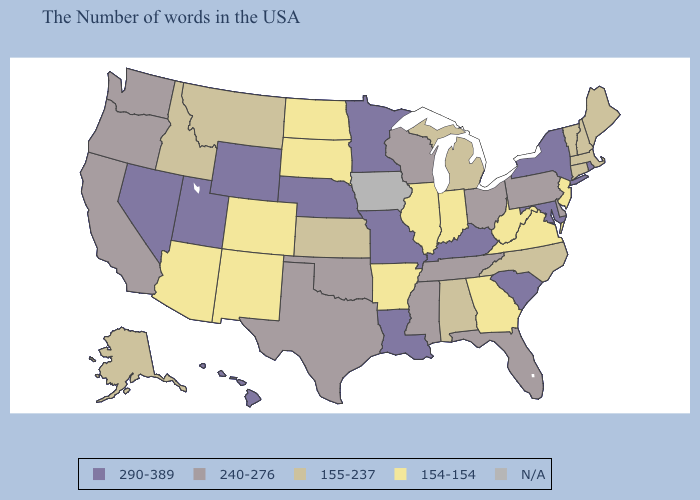Name the states that have a value in the range 154-154?
Give a very brief answer. New Jersey, Virginia, West Virginia, Georgia, Indiana, Illinois, Arkansas, South Dakota, North Dakota, Colorado, New Mexico, Arizona. Which states hav the highest value in the West?
Keep it brief. Wyoming, Utah, Nevada, Hawaii. Among the states that border Nebraska , does Wyoming have the lowest value?
Answer briefly. No. Among the states that border Arizona , which have the highest value?
Answer briefly. Utah, Nevada. Does Nevada have the highest value in the USA?
Give a very brief answer. Yes. Which states have the lowest value in the USA?
Keep it brief. New Jersey, Virginia, West Virginia, Georgia, Indiana, Illinois, Arkansas, South Dakota, North Dakota, Colorado, New Mexico, Arizona. What is the value of Kentucky?
Be succinct. 290-389. What is the highest value in the USA?
Concise answer only. 290-389. Does Wyoming have the lowest value in the USA?
Keep it brief. No. Among the states that border Arkansas , which have the lowest value?
Short answer required. Tennessee, Mississippi, Oklahoma, Texas. What is the value of Tennessee?
Write a very short answer. 240-276. Which states hav the highest value in the MidWest?
Give a very brief answer. Missouri, Minnesota, Nebraska. Name the states that have a value in the range 154-154?
Quick response, please. New Jersey, Virginia, West Virginia, Georgia, Indiana, Illinois, Arkansas, South Dakota, North Dakota, Colorado, New Mexico, Arizona. Among the states that border Florida , does Alabama have the lowest value?
Answer briefly. No. 